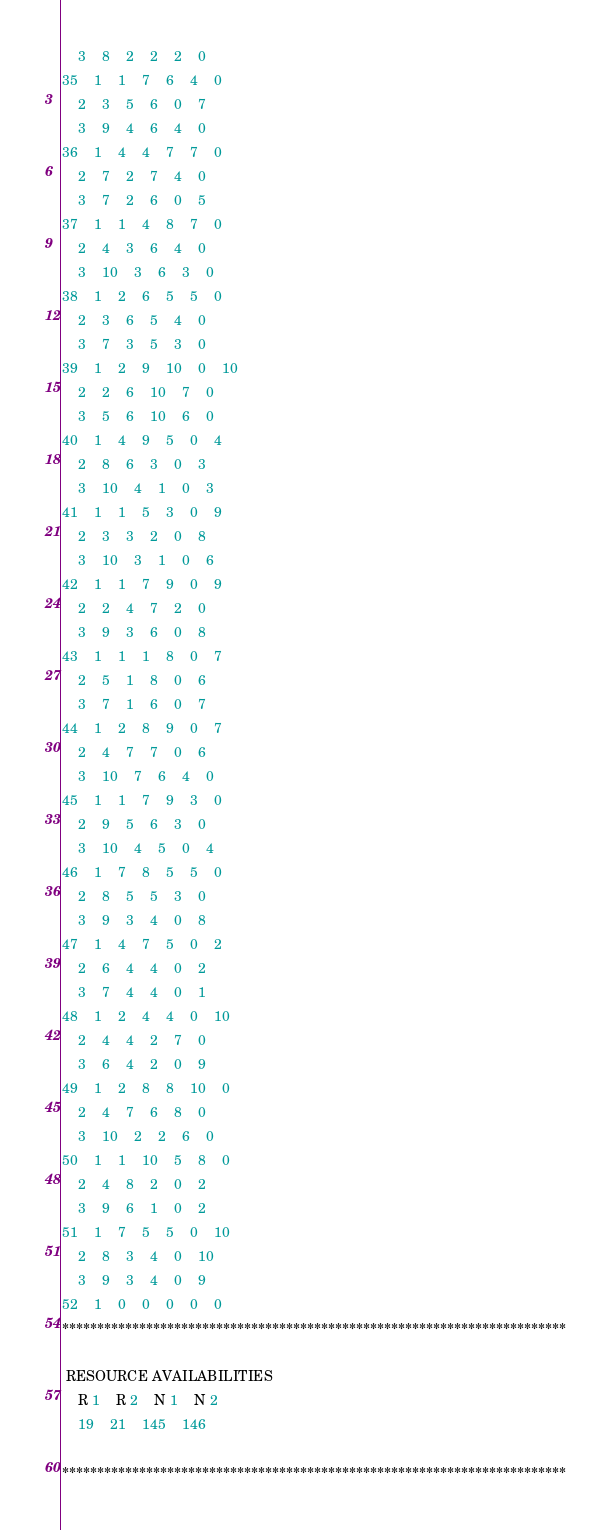<code> <loc_0><loc_0><loc_500><loc_500><_ObjectiveC_>	3	8	2	2	2	0	
35	1	1	7	6	4	0	
	2	3	5	6	0	7	
	3	9	4	6	4	0	
36	1	4	4	7	7	0	
	2	7	2	7	4	0	
	3	7	2	6	0	5	
37	1	1	4	8	7	0	
	2	4	3	6	4	0	
	3	10	3	6	3	0	
38	1	2	6	5	5	0	
	2	3	6	5	4	0	
	3	7	3	5	3	0	
39	1	2	9	10	0	10	
	2	2	6	10	7	0	
	3	5	6	10	6	0	
40	1	4	9	5	0	4	
	2	8	6	3	0	3	
	3	10	4	1	0	3	
41	1	1	5	3	0	9	
	2	3	3	2	0	8	
	3	10	3	1	0	6	
42	1	1	7	9	0	9	
	2	2	4	7	2	0	
	3	9	3	6	0	8	
43	1	1	1	8	0	7	
	2	5	1	8	0	6	
	3	7	1	6	0	7	
44	1	2	8	9	0	7	
	2	4	7	7	0	6	
	3	10	7	6	4	0	
45	1	1	7	9	3	0	
	2	9	5	6	3	0	
	3	10	4	5	0	4	
46	1	7	8	5	5	0	
	2	8	5	5	3	0	
	3	9	3	4	0	8	
47	1	4	7	5	0	2	
	2	6	4	4	0	2	
	3	7	4	4	0	1	
48	1	2	4	4	0	10	
	2	4	4	2	7	0	
	3	6	4	2	0	9	
49	1	2	8	8	10	0	
	2	4	7	6	8	0	
	3	10	2	2	6	0	
50	1	1	10	5	8	0	
	2	4	8	2	0	2	
	3	9	6	1	0	2	
51	1	7	5	5	0	10	
	2	8	3	4	0	10	
	3	9	3	4	0	9	
52	1	0	0	0	0	0	
************************************************************************

 RESOURCE AVAILABILITIES 
	R 1	R 2	N 1	N 2
	19	21	145	146

************************************************************************
</code> 